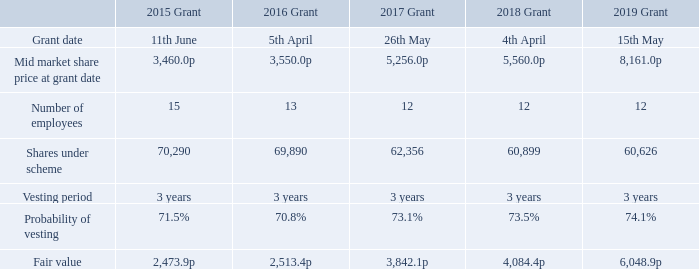Performance Share Plan
The relevant disclosures in respect of the Performance Share Plan grants are set out below.
What are the relevant disclosures in the table pertaining to? In respect of the performance share plan grants. What was the number of employees under the 2015 Grant? 15. For which years were the relevant disclosures in respect of the Performance Share Plan grants set out? 2015, 2016, 2017, 2018, 2019. In which year's grant had the largest number of employees? 15>13>12
Answer: 2015. What was the change in the number of shares under scheme under the 2019 Grant from the 2018 Grant? 60,626-60,899
Answer: -273. What was the percentage change in the number of shares under scheme under the 2019 Grant from the 2018 Grant?
Answer scale should be: percent. (60,626-60,899)/60,899
Answer: -0.45. 